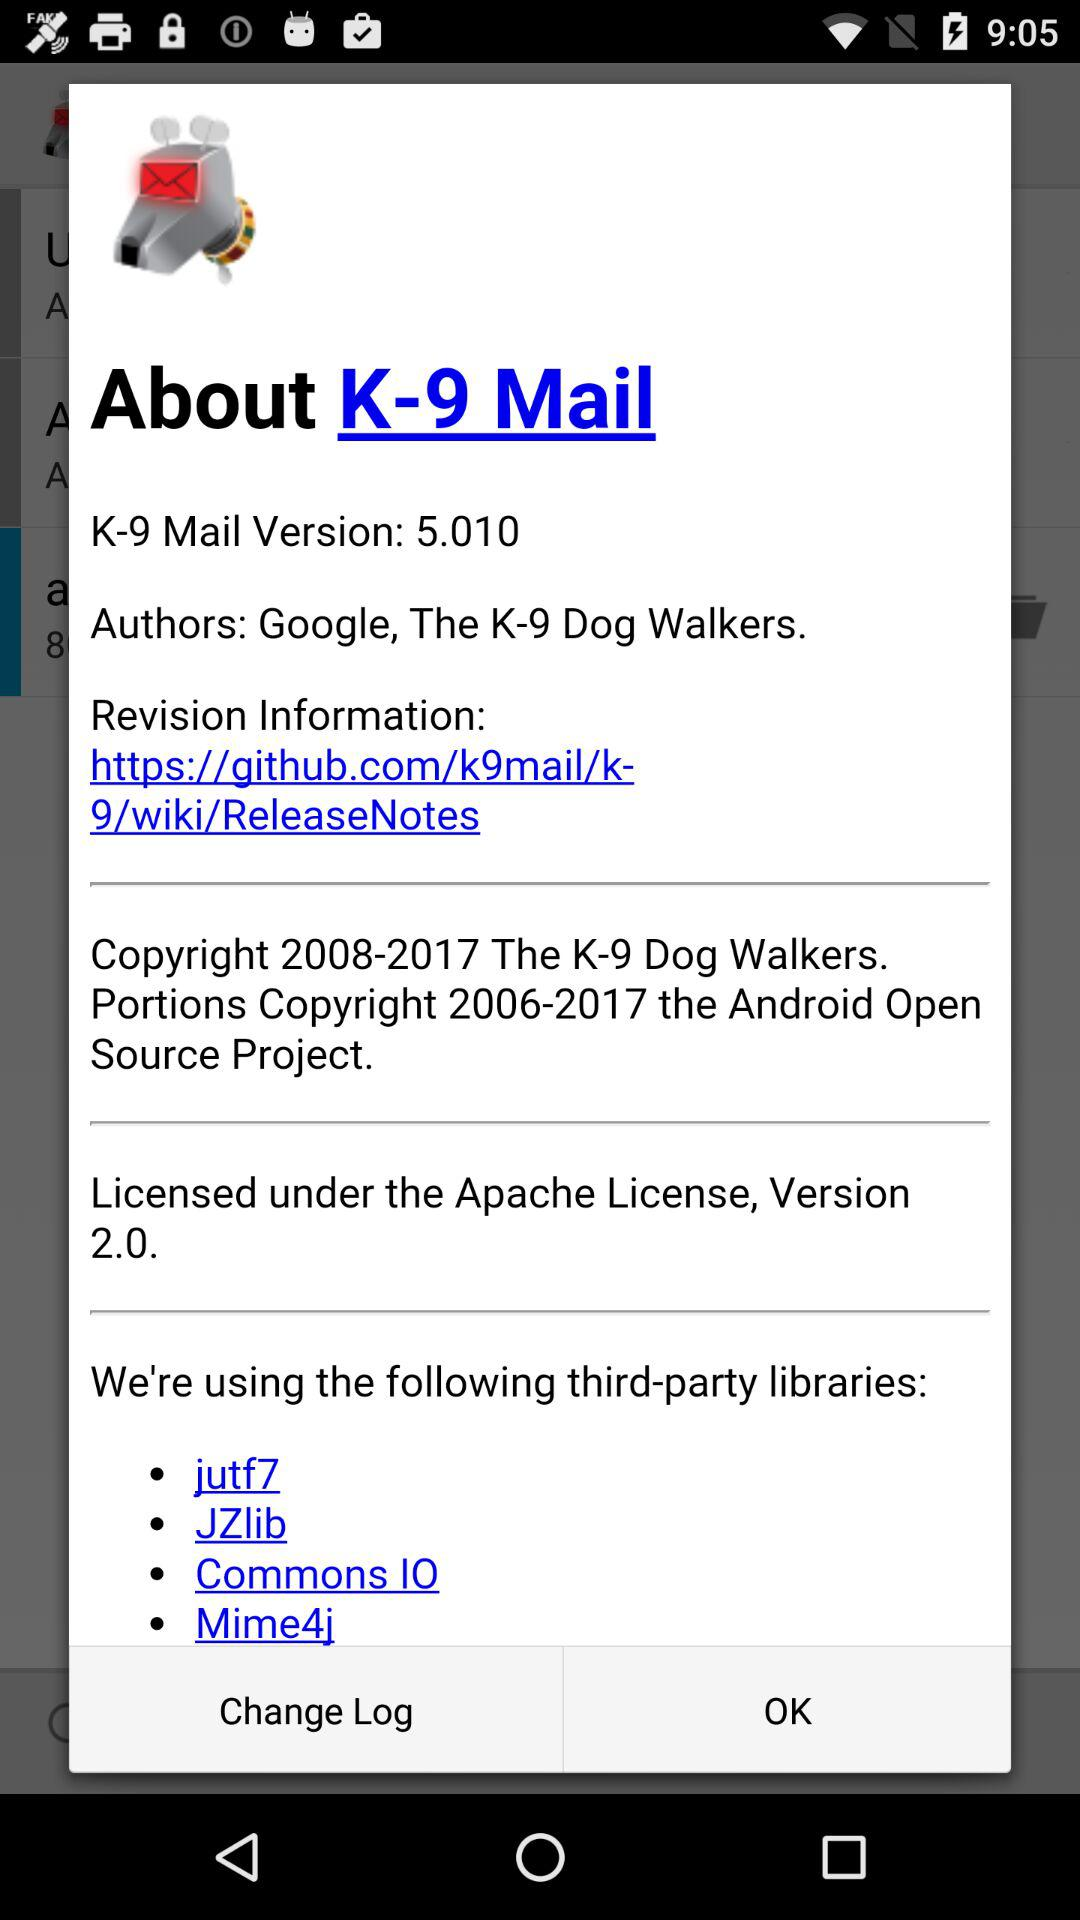How many third-party libraries are used by K-9 Mail?
Answer the question using a single word or phrase. 4 